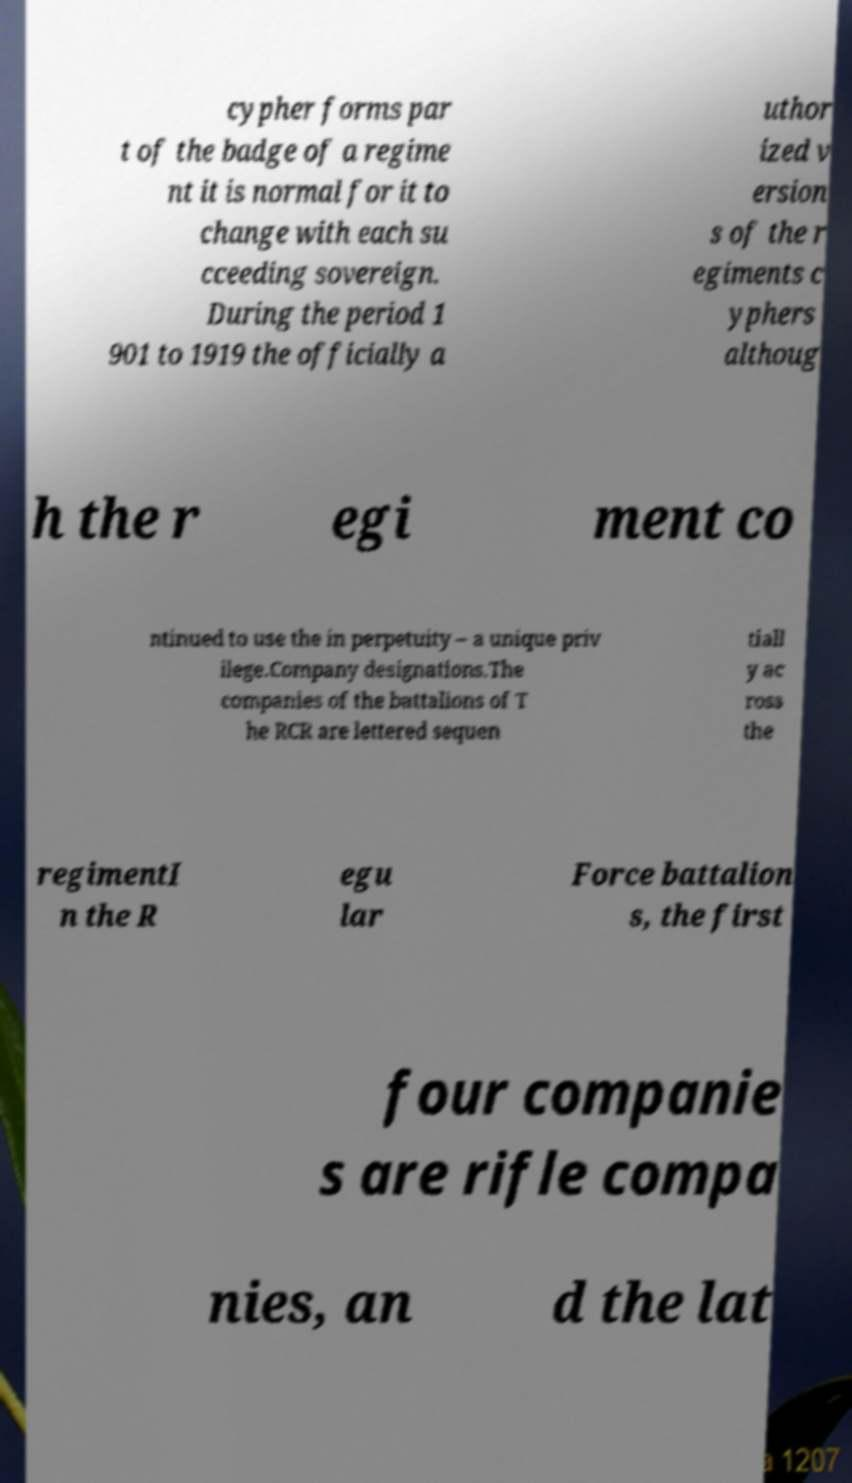I need the written content from this picture converted into text. Can you do that? cypher forms par t of the badge of a regime nt it is normal for it to change with each su cceeding sovereign. During the period 1 901 to 1919 the officially a uthor ized v ersion s of the r egiments c yphers althoug h the r egi ment co ntinued to use the in perpetuity – a unique priv ilege.Company designations.The companies of the battalions of T he RCR are lettered sequen tiall y ac ross the regimentI n the R egu lar Force battalion s, the first four companie s are rifle compa nies, an d the lat 